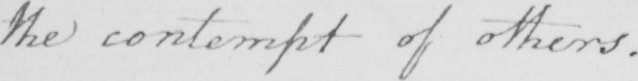Can you read and transcribe this handwriting? the contempt of others . 